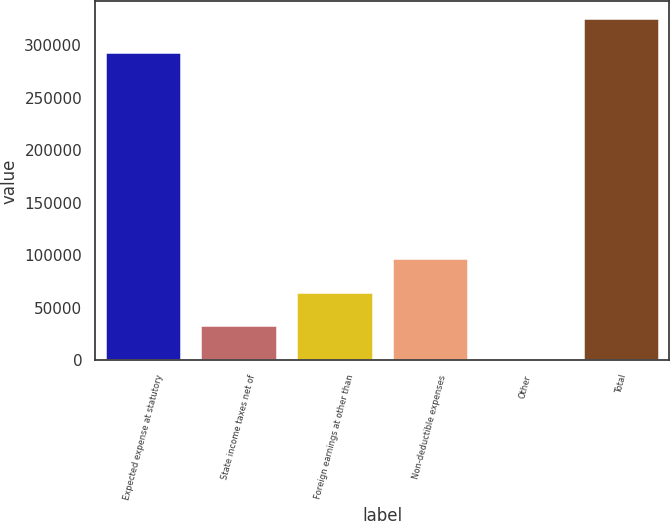<chart> <loc_0><loc_0><loc_500><loc_500><bar_chart><fcel>Expected expense at statutory<fcel>State income taxes net of<fcel>Foreign earnings at other than<fcel>Non-deductible expenses<fcel>Other<fcel>Total<nl><fcel>293279<fcel>33448.2<fcel>65487.4<fcel>97526.6<fcel>1409<fcel>325318<nl></chart> 